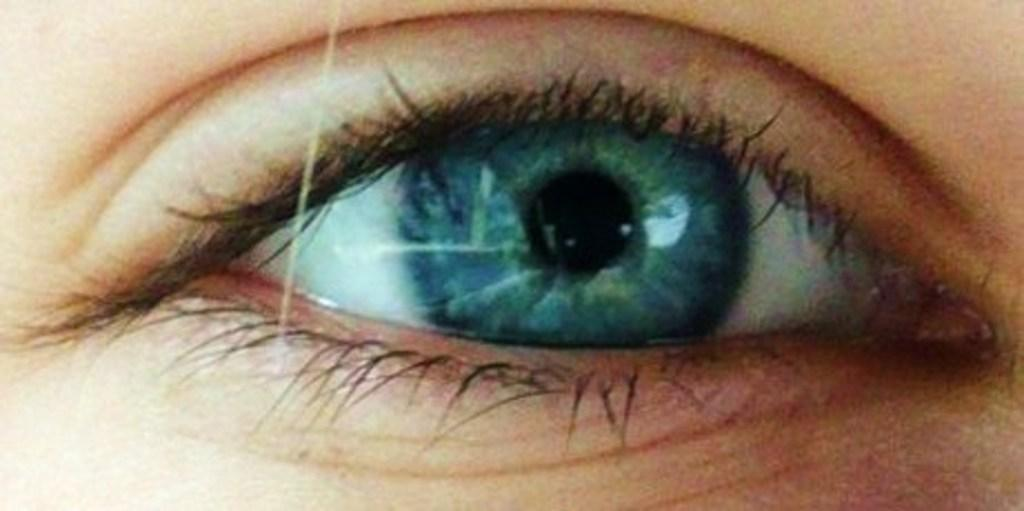What is the main subject of the image? The main subject of the image is an eye. Can you describe the colors of the eye in the image? The eye has white, blue, and black colors. What direction is the box facing in the image? There is no box present in the image, so this question cannot be answered. 